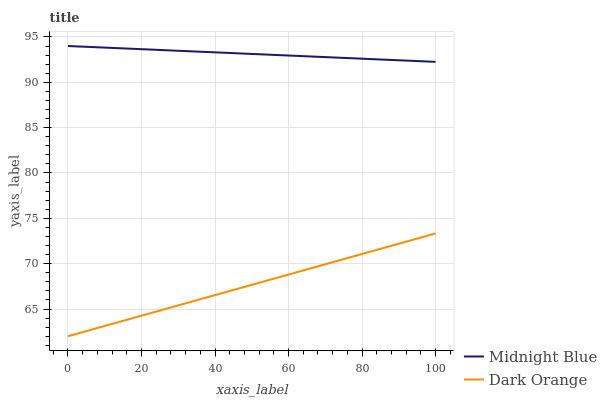Does Dark Orange have the minimum area under the curve?
Answer yes or no. Yes. Does Midnight Blue have the maximum area under the curve?
Answer yes or no. Yes. Does Midnight Blue have the minimum area under the curve?
Answer yes or no. No. Is Dark Orange the smoothest?
Answer yes or no. Yes. Is Midnight Blue the roughest?
Answer yes or no. Yes. Is Midnight Blue the smoothest?
Answer yes or no. No. Does Dark Orange have the lowest value?
Answer yes or no. Yes. Does Midnight Blue have the lowest value?
Answer yes or no. No. Does Midnight Blue have the highest value?
Answer yes or no. Yes. Is Dark Orange less than Midnight Blue?
Answer yes or no. Yes. Is Midnight Blue greater than Dark Orange?
Answer yes or no. Yes. Does Dark Orange intersect Midnight Blue?
Answer yes or no. No. 